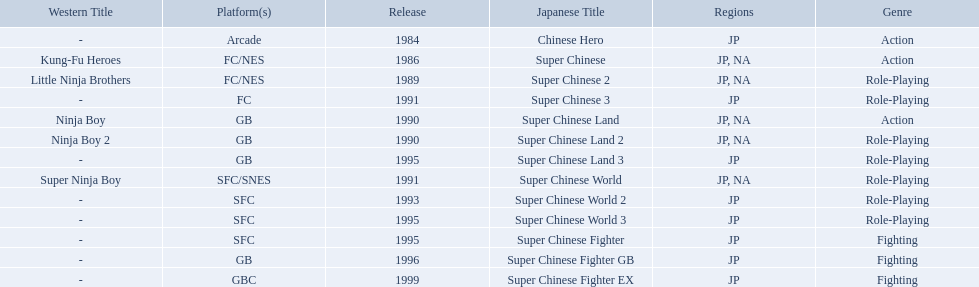Which titles were released in north america? Super Chinese, Super Chinese 2, Super Chinese Land, Super Chinese Land 2, Super Chinese World. Of those, which had the least releases? Super Chinese World. 